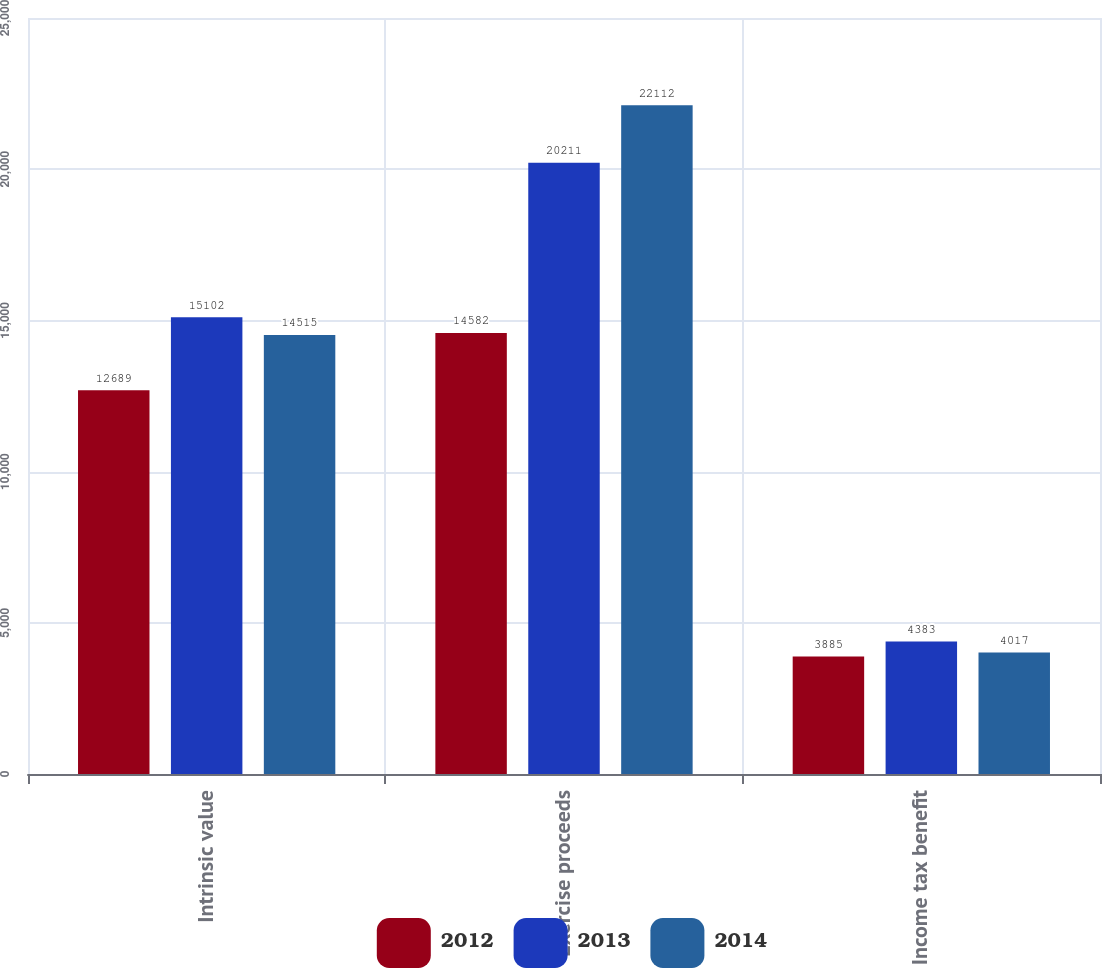Convert chart. <chart><loc_0><loc_0><loc_500><loc_500><stacked_bar_chart><ecel><fcel>Intrinsic value<fcel>Exercise proceeds<fcel>Income tax benefit<nl><fcel>2012<fcel>12689<fcel>14582<fcel>3885<nl><fcel>2013<fcel>15102<fcel>20211<fcel>4383<nl><fcel>2014<fcel>14515<fcel>22112<fcel>4017<nl></chart> 